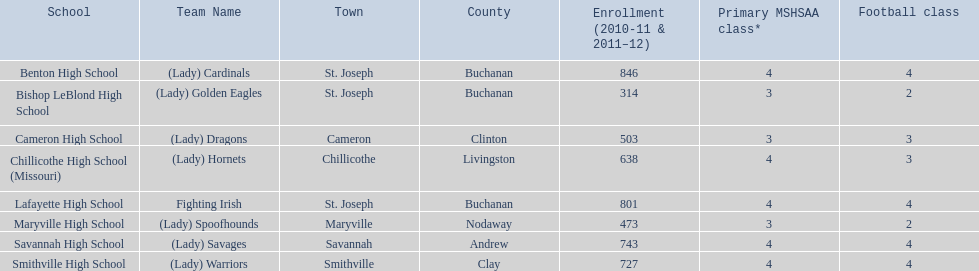Would you mind parsing the complete table? {'header': ['School', 'Team Name', 'Town', 'County', 'Enrollment (2010-11 & 2011–12)', 'Primary MSHSAA class*', 'Football class'], 'rows': [['Benton High School', '(Lady) Cardinals', 'St. Joseph', 'Buchanan', '846', '4', '4'], ['Bishop LeBlond High School', '(Lady) Golden Eagles', 'St. Joseph', 'Buchanan', '314', '3', '2'], ['Cameron High School', '(Lady) Dragons', 'Cameron', 'Clinton', '503', '3', '3'], ['Chillicothe High School (Missouri)', '(Lady) Hornets', 'Chillicothe', 'Livingston', '638', '4', '3'], ['Lafayette High School', 'Fighting Irish', 'St. Joseph', 'Buchanan', '801', '4', '4'], ['Maryville High School', '(Lady) Spoofhounds', 'Maryville', 'Nodaway', '473', '3', '2'], ['Savannah High School', '(Lady) Savages', 'Savannah', 'Andrew', '743', '4', '4'], ['Smithville High School', '(Lady) Warriors', 'Smithville', 'Clay', '727', '4', '4']]} Which group utilizes green and grey as their hues? Fighting Irish. What is this group's name? Lafayette High School. 